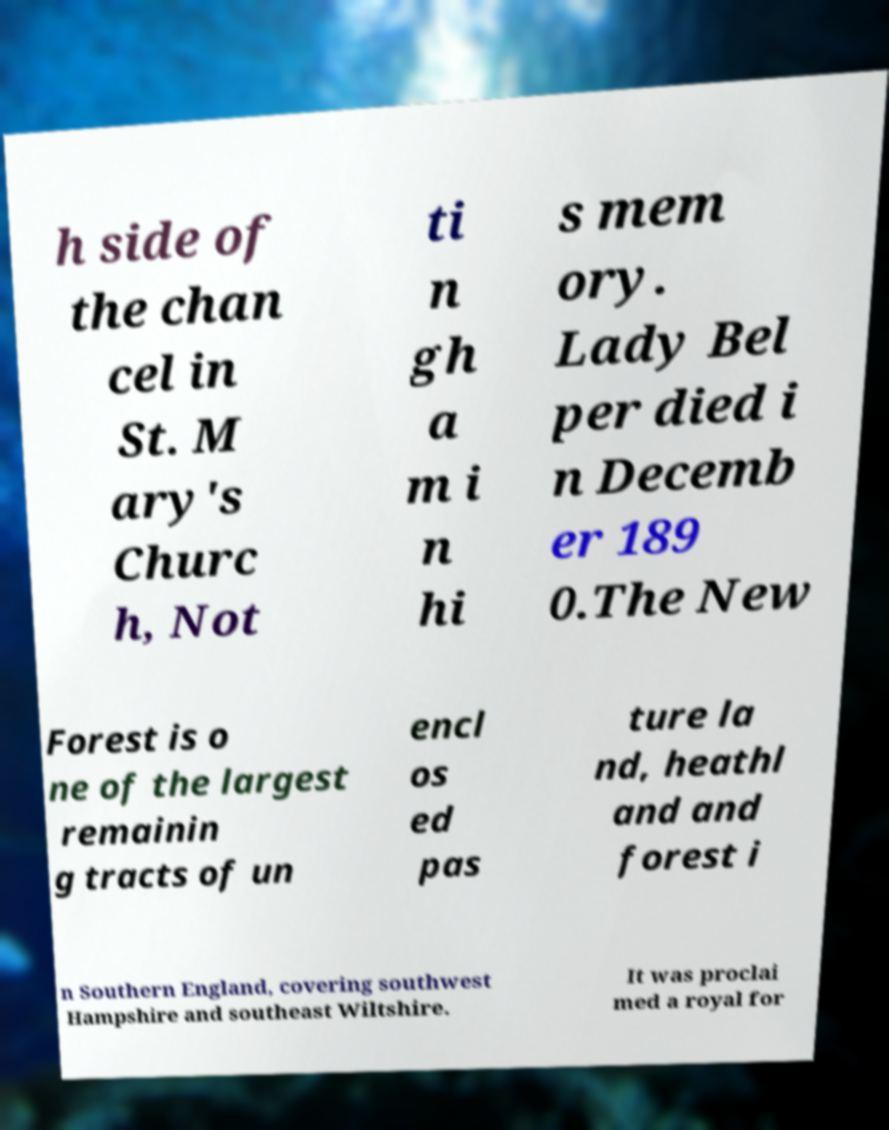Can you accurately transcribe the text from the provided image for me? h side of the chan cel in St. M ary's Churc h, Not ti n gh a m i n hi s mem ory. Lady Bel per died i n Decemb er 189 0.The New Forest is o ne of the largest remainin g tracts of un encl os ed pas ture la nd, heathl and and forest i n Southern England, covering southwest Hampshire and southeast Wiltshire. It was proclai med a royal for 